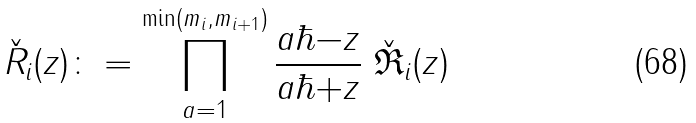Convert formula to latex. <formula><loc_0><loc_0><loc_500><loc_500>\check { R } _ { i } ( z ) \colon = \prod _ { a = 1 } ^ { \min ( m _ { i } , m _ { i + 1 } ) } \frac { a \hbar { - } z } { a \hbar { + } z } \ \check { \mathfrak R } _ { i } ( z )</formula> 